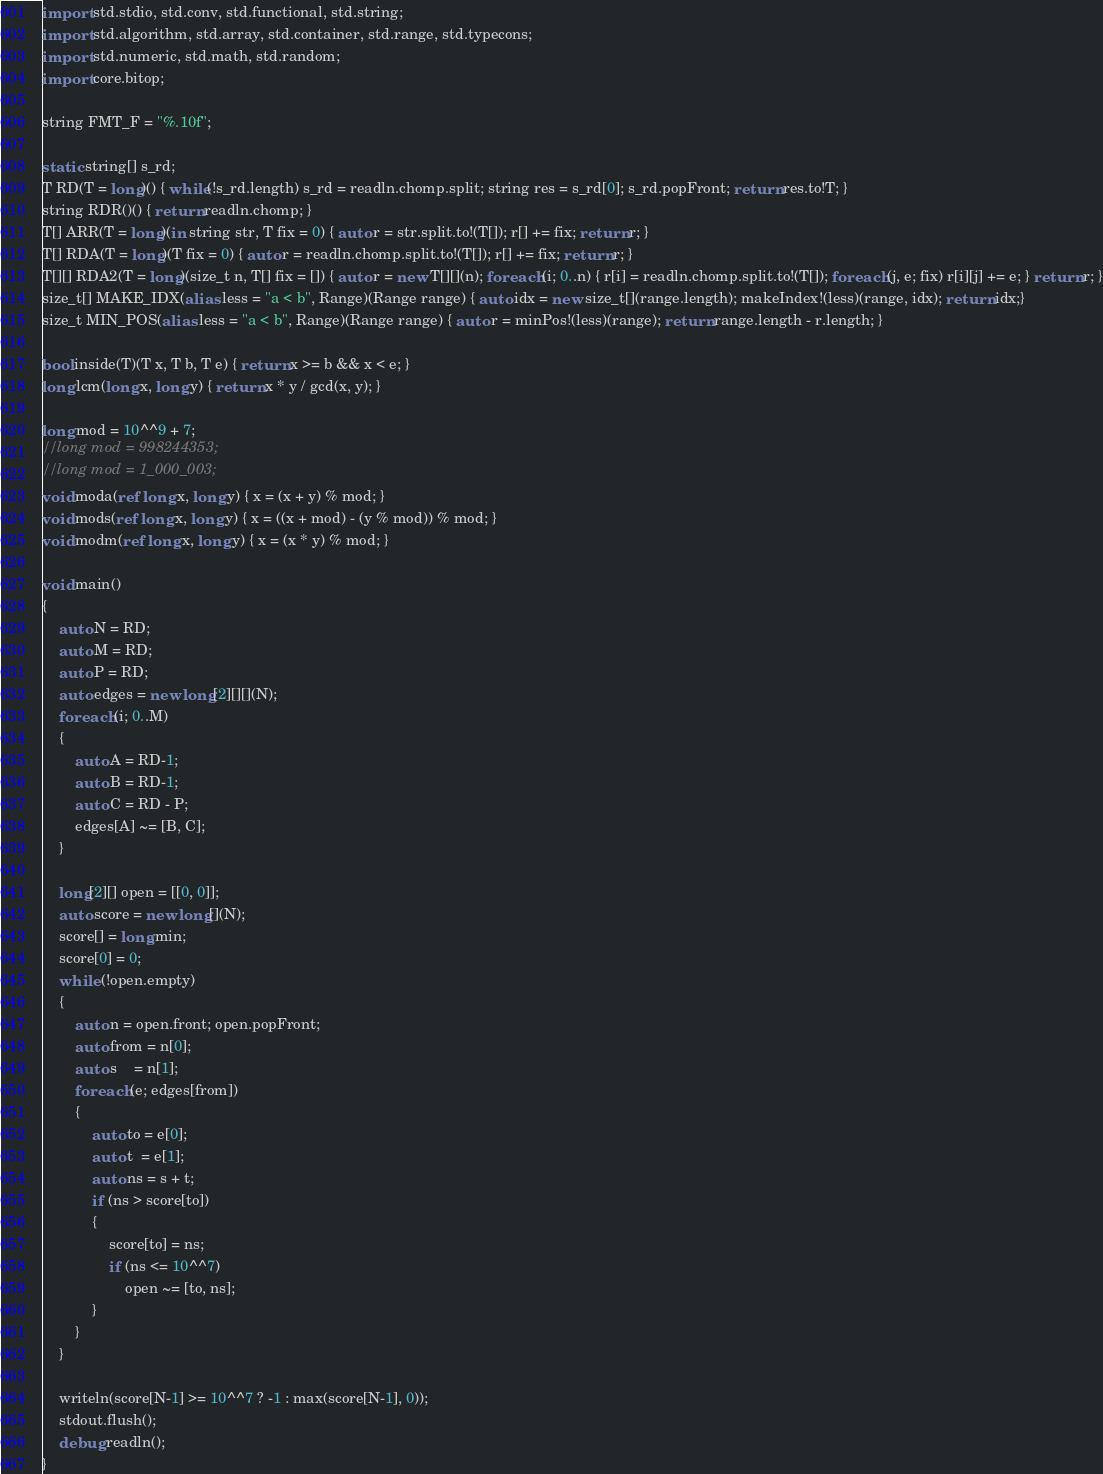<code> <loc_0><loc_0><loc_500><loc_500><_D_>import std.stdio, std.conv, std.functional, std.string;
import std.algorithm, std.array, std.container, std.range, std.typecons;
import std.numeric, std.math, std.random;
import core.bitop;

string FMT_F = "%.10f";

static string[] s_rd;
T RD(T = long)() { while(!s_rd.length) s_rd = readln.chomp.split; string res = s_rd[0]; s_rd.popFront; return res.to!T; }
string RDR()() { return readln.chomp; }
T[] ARR(T = long)(in string str, T fix = 0) { auto r = str.split.to!(T[]); r[] += fix; return r; }
T[] RDA(T = long)(T fix = 0) { auto r = readln.chomp.split.to!(T[]); r[] += fix; return r; }
T[][] RDA2(T = long)(size_t n, T[] fix = []) { auto r = new T[][](n); foreach (i; 0..n) { r[i] = readln.chomp.split.to!(T[]); foreach (j, e; fix) r[i][j] += e; } return r; }
size_t[] MAKE_IDX(alias less = "a < b", Range)(Range range) { auto idx = new size_t[](range.length); makeIndex!(less)(range, idx); return idx;}
size_t MIN_POS(alias less = "a < b", Range)(Range range) { auto r = minPos!(less)(range); return range.length - r.length; }

bool inside(T)(T x, T b, T e) { return x >= b && x < e; }
long lcm(long x, long y) { return x * y / gcd(x, y); }

long mod = 10^^9 + 7;
//long mod = 998244353;
//long mod = 1_000_003;
void moda(ref long x, long y) { x = (x + y) % mod; }
void mods(ref long x, long y) { x = ((x + mod) - (y % mod)) % mod; }
void modm(ref long x, long y) { x = (x * y) % mod; }

void main()
{
	auto N = RD;
	auto M = RD;
	auto P = RD;
	auto edges = new long[2][][](N);
	foreach (i; 0..M)
	{
		auto A = RD-1;
		auto B = RD-1;
		auto C = RD - P;
		edges[A] ~= [B, C];
	}

	long[2][] open = [[0, 0]];
	auto score = new long[](N);
	score[] = long.min;
	score[0] = 0;
	while (!open.empty)
	{
		auto n = open.front; open.popFront;
		auto from = n[0];
		auto s    = n[1];
		foreach (e; edges[from])
		{
			auto to = e[0];
			auto t  = e[1];
			auto ns = s + t;
			if (ns > score[to])
			{
				score[to] = ns;
				if (ns <= 10^^7)
					open ~= [to, ns];
			}
		}
	}

	writeln(score[N-1] >= 10^^7 ? -1 : max(score[N-1], 0));
	stdout.flush();
	debug readln();
}</code> 